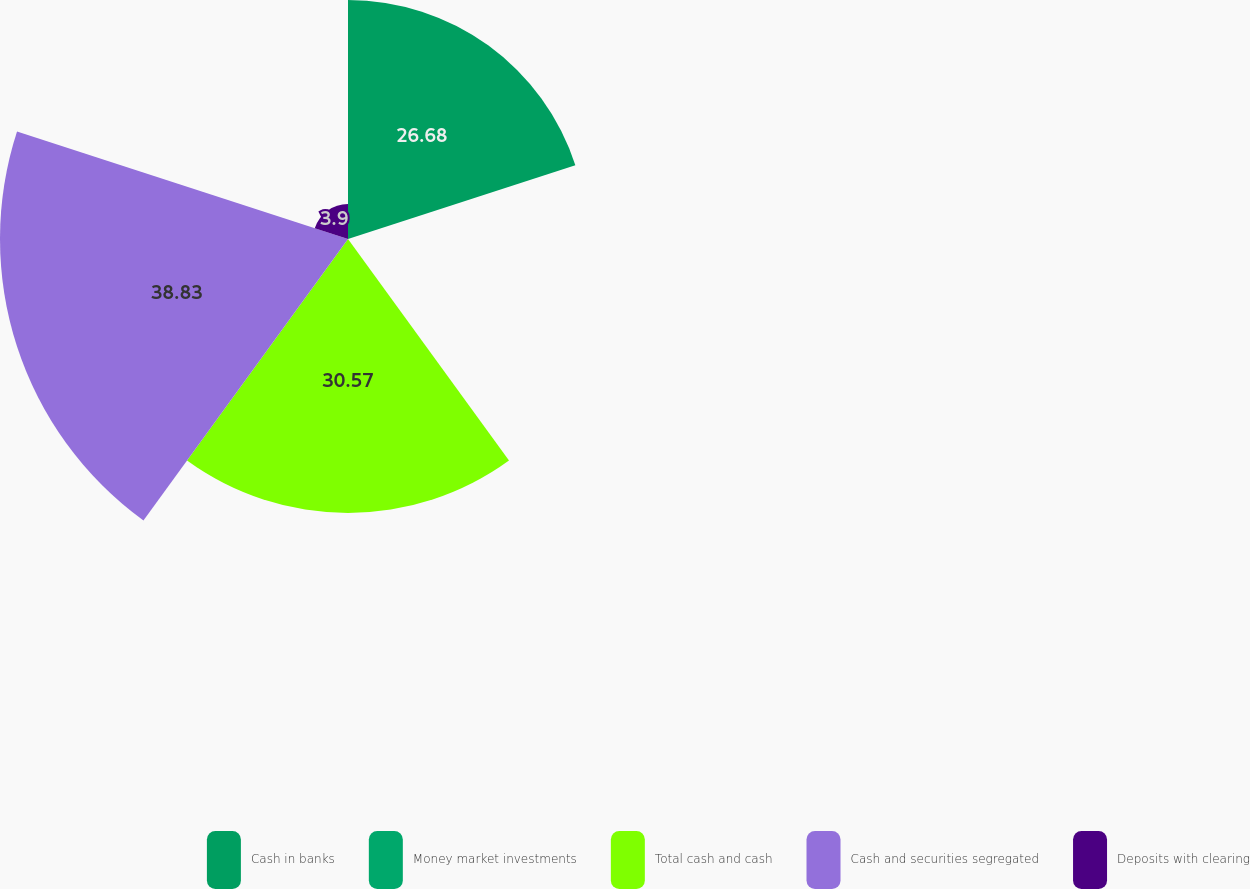<chart> <loc_0><loc_0><loc_500><loc_500><pie_chart><fcel>Cash in banks<fcel>Money market investments<fcel>Total cash and cash<fcel>Cash and securities segregated<fcel>Deposits with clearing<nl><fcel>26.68%<fcel>0.02%<fcel>30.57%<fcel>38.84%<fcel>3.9%<nl></chart> 